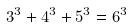<formula> <loc_0><loc_0><loc_500><loc_500>3 ^ { 3 } + 4 ^ { 3 } + 5 ^ { 3 } = 6 ^ { 3 }</formula> 